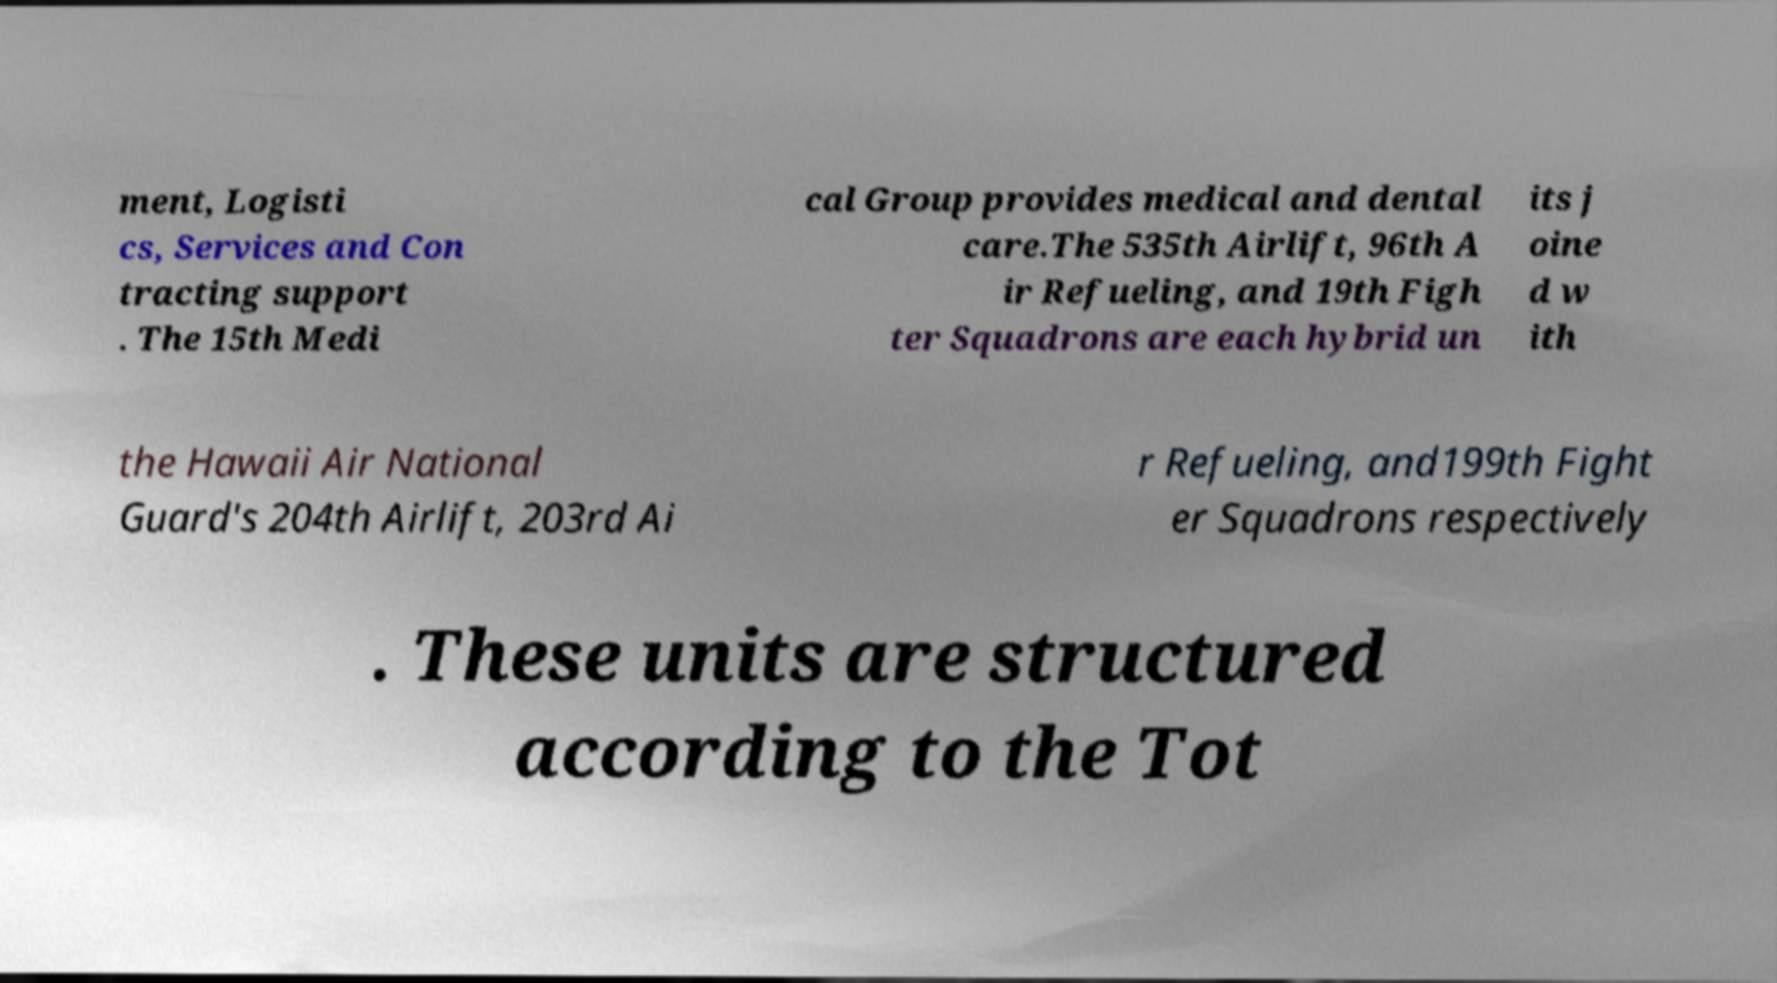Can you accurately transcribe the text from the provided image for me? ment, Logisti cs, Services and Con tracting support . The 15th Medi cal Group provides medical and dental care.The 535th Airlift, 96th A ir Refueling, and 19th Figh ter Squadrons are each hybrid un its j oine d w ith the Hawaii Air National Guard's 204th Airlift, 203rd Ai r Refueling, and199th Fight er Squadrons respectively . These units are structured according to the Tot 